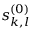Convert formula to latex. <formula><loc_0><loc_0><loc_500><loc_500>s _ { k , l } ^ { ( 0 ) }</formula> 